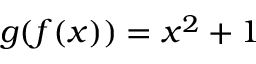<formula> <loc_0><loc_0><loc_500><loc_500>g ( f ( x ) ) = x ^ { 2 } + 1</formula> 